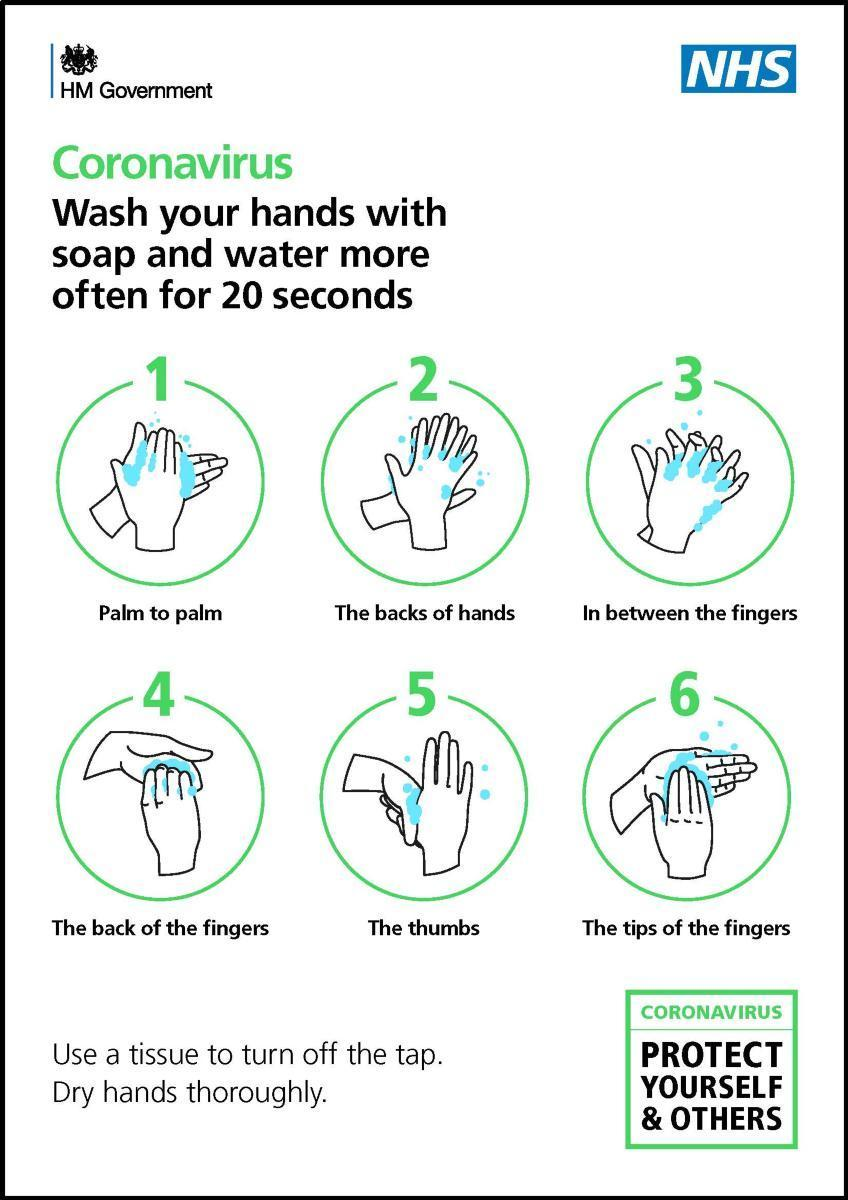How many ways of washing the hands are shown in this infographic image?
Answer the question with a short phrase. 6 